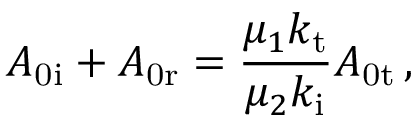Convert formula to latex. <formula><loc_0><loc_0><loc_500><loc_500>A _ { 0 i } + A _ { 0 r } = \frac { \mu _ { 1 } k _ { t } } { \mu _ { 2 } k _ { i } } A _ { 0 t } \, ,</formula> 